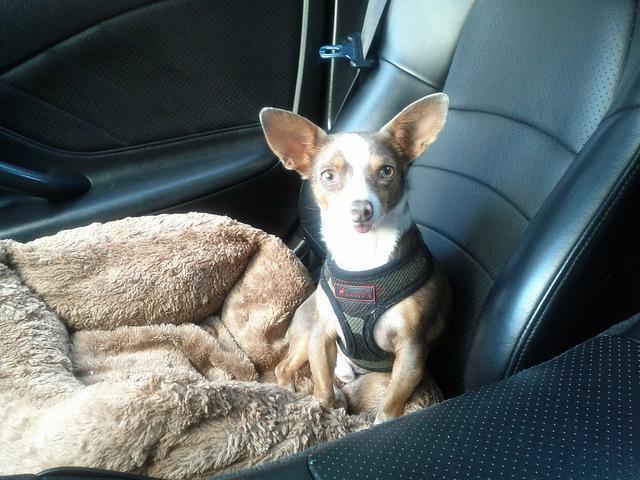How many people are wearing purple headbands?
Give a very brief answer. 0. 